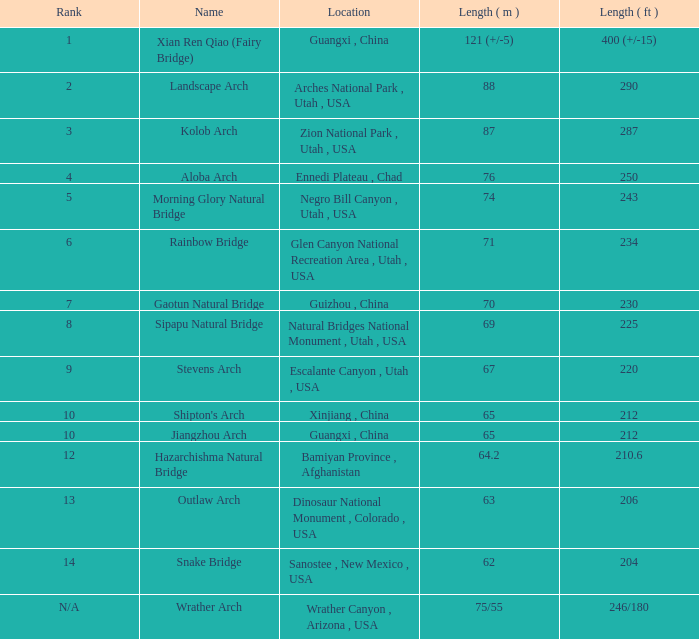2-meter-long arch be found? Bamiyan Province , Afghanistan. 